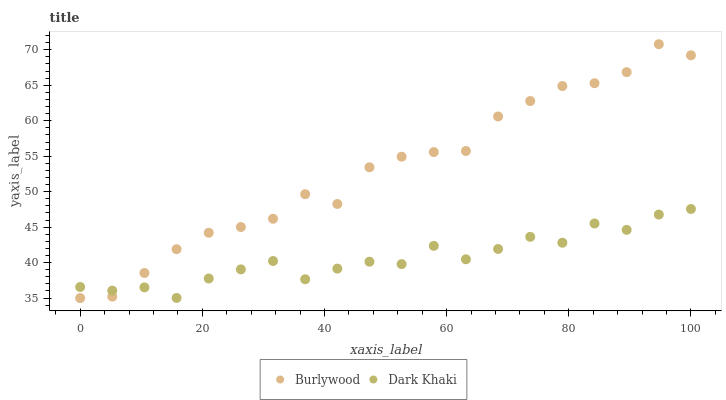Does Dark Khaki have the minimum area under the curve?
Answer yes or no. Yes. Does Burlywood have the maximum area under the curve?
Answer yes or no. Yes. Does Dark Khaki have the maximum area under the curve?
Answer yes or no. No. Is Burlywood the smoothest?
Answer yes or no. Yes. Is Dark Khaki the roughest?
Answer yes or no. Yes. Is Dark Khaki the smoothest?
Answer yes or no. No. Does Burlywood have the lowest value?
Answer yes or no. Yes. Does Dark Khaki have the lowest value?
Answer yes or no. No. Does Burlywood have the highest value?
Answer yes or no. Yes. Does Dark Khaki have the highest value?
Answer yes or no. No. Does Burlywood intersect Dark Khaki?
Answer yes or no. Yes. Is Burlywood less than Dark Khaki?
Answer yes or no. No. Is Burlywood greater than Dark Khaki?
Answer yes or no. No. 